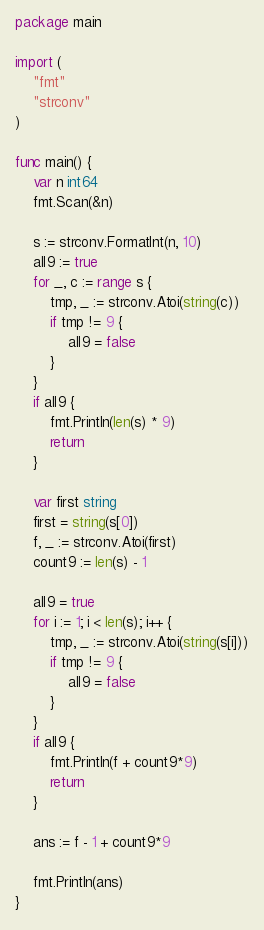Convert code to text. <code><loc_0><loc_0><loc_500><loc_500><_Go_>package main

import (
	"fmt"
	"strconv"
)

func main() {
	var n int64
	fmt.Scan(&n)

	s := strconv.FormatInt(n, 10)
	all9 := true
	for _, c := range s {
		tmp, _ := strconv.Atoi(string(c))
		if tmp != 9 {
			all9 = false
		}
	}
	if all9 {
		fmt.Println(len(s) * 9)
		return
	}

	var first string
	first = string(s[0])
	f, _ := strconv.Atoi(first)
	count9 := len(s) - 1

	all9 = true
	for i := 1; i < len(s); i++ {
		tmp, _ := strconv.Atoi(string(s[i]))
		if tmp != 9 {
			all9 = false
		}
	}
	if all9 {
		fmt.Println(f + count9*9)
		return
	}

	ans := f - 1 + count9*9

	fmt.Println(ans)
}
</code> 